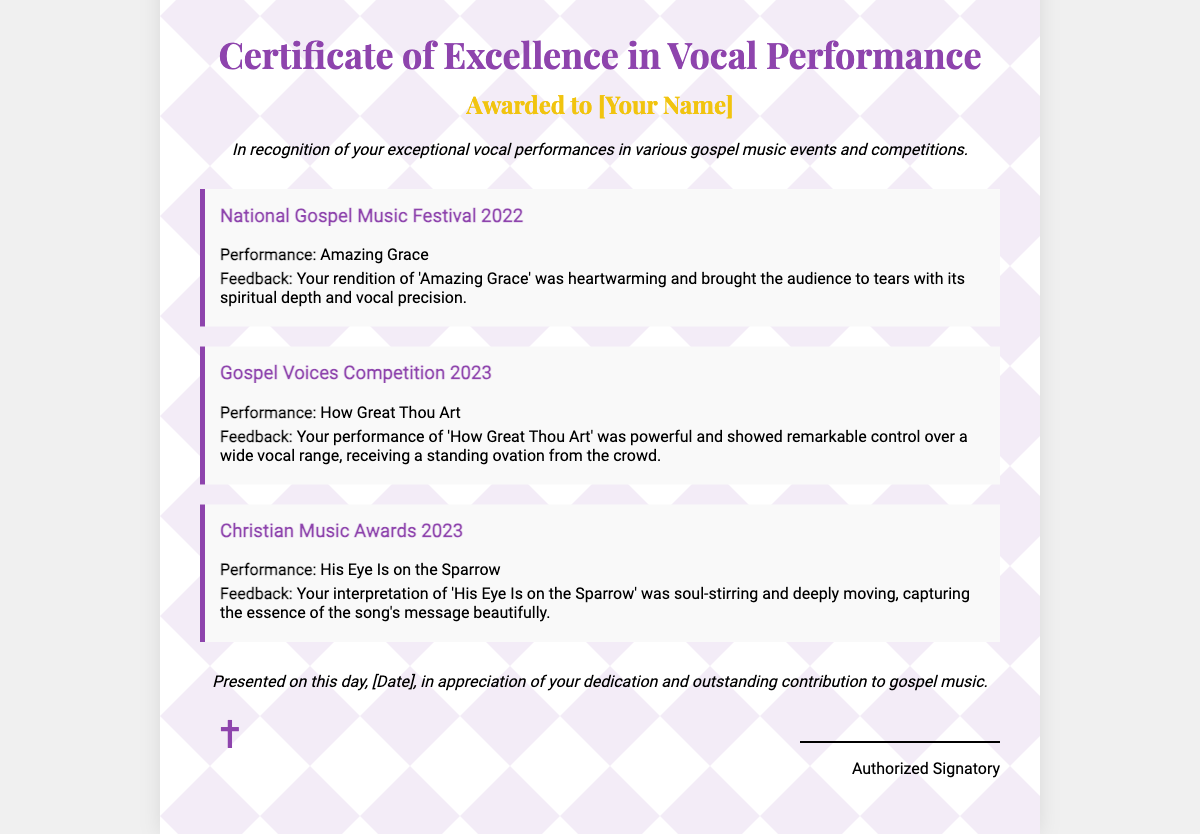What is the title of the certificate? The title is prominently displayed at the top of the document, stating the purpose of the certificate.
Answer: Certificate of Excellence in Vocal Performance Who is the certificate awarded to? The recipient's name is included in the document directly beneath the title.
Answer: [Your Name] What event was performance number one in? The first performance is linked to a specific event that illustrates the recipient's achievement in gospel music.
Answer: National Gospel Music Festival 2022 What piece was performed at the Gospel Voices Competition 2023? This performance title is specified within the document and showcases the recipient's skill at that event.
Answer: How Great Thou Art What is the overall feedback for the performance of "Amazing Grace"? The feedback provides an emotional response from the audience regarding the first performance, highlighting its impact.
Answer: heartwarming and brought the audience to tears How many performances are highlighted in the certificate? The number of performances mentioned in the document can be counted from the respective sections provided.
Answer: 3 What is the spiritual symbol included in the design? A symbol is used at the bottom of the certificate to enhance its spiritual theme.
Answer: ✝ On what date is the certificate presented? The date of presentation is included towards the end of the document but remains a placeholder for the actual date.
Answer: [Date] What motif is incorporated within the certificate design? The document features a specific artistic theme that reflects the nature of the award.
Answer: spiritual motif Who signs the certificate? The document provides information regarding the person authorizing the certificate, signifying credibility.
Answer: Authorized Signatory 